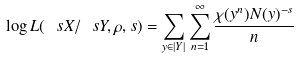<formula> <loc_0><loc_0><loc_500><loc_500>\log L ( \ s X / \ s Y , \rho , s ) = \sum _ { y \in | Y | } \sum _ { n = 1 } ^ { \infty } \frac { \chi ( y ^ { n } ) N ( y ) ^ { - s } } { n }</formula> 